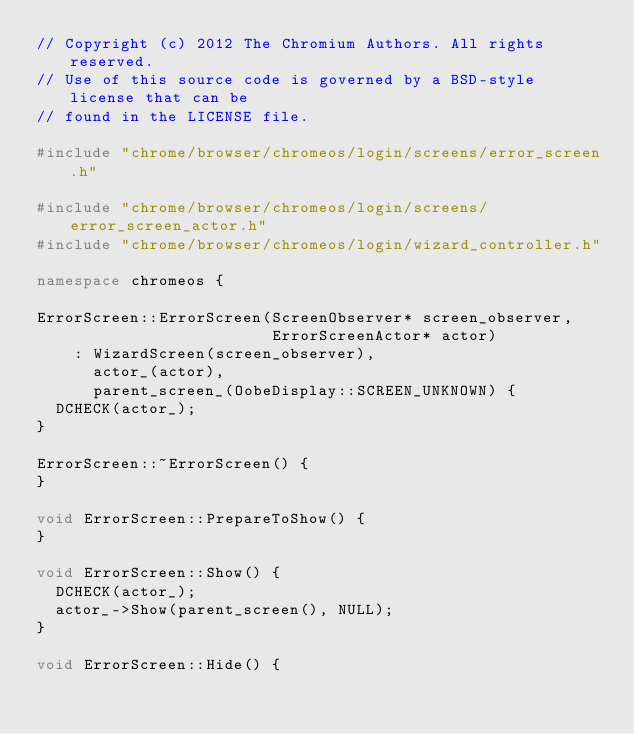Convert code to text. <code><loc_0><loc_0><loc_500><loc_500><_C++_>// Copyright (c) 2012 The Chromium Authors. All rights reserved.
// Use of this source code is governed by a BSD-style license that can be
// found in the LICENSE file.

#include "chrome/browser/chromeos/login/screens/error_screen.h"

#include "chrome/browser/chromeos/login/screens/error_screen_actor.h"
#include "chrome/browser/chromeos/login/wizard_controller.h"

namespace chromeos {

ErrorScreen::ErrorScreen(ScreenObserver* screen_observer,
                         ErrorScreenActor* actor)
    : WizardScreen(screen_observer),
      actor_(actor),
      parent_screen_(OobeDisplay::SCREEN_UNKNOWN) {
  DCHECK(actor_);
}

ErrorScreen::~ErrorScreen() {
}

void ErrorScreen::PrepareToShow() {
}

void ErrorScreen::Show() {
  DCHECK(actor_);
  actor_->Show(parent_screen(), NULL);
}

void ErrorScreen::Hide() {</code> 